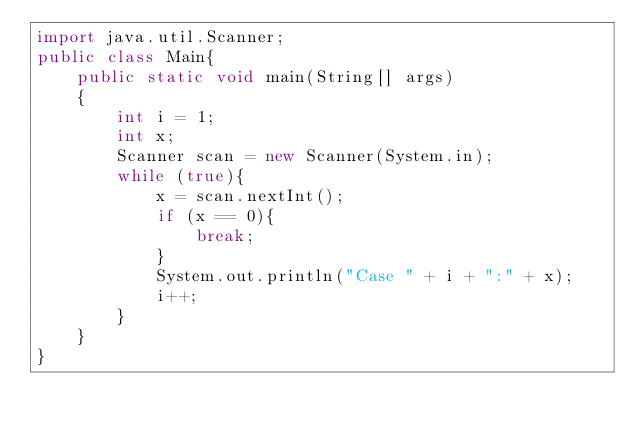Convert code to text. <code><loc_0><loc_0><loc_500><loc_500><_Java_>import java.util.Scanner;
public class Main{
    public static void main(String[] args)
    {
        int i = 1;
        int x;
        Scanner scan = new Scanner(System.in);
        while (true){
            x = scan.nextInt();
            if (x == 0){
                break;
            }
            System.out.println("Case " + i + ":" + x);
            i++;
        }
    }
}</code> 